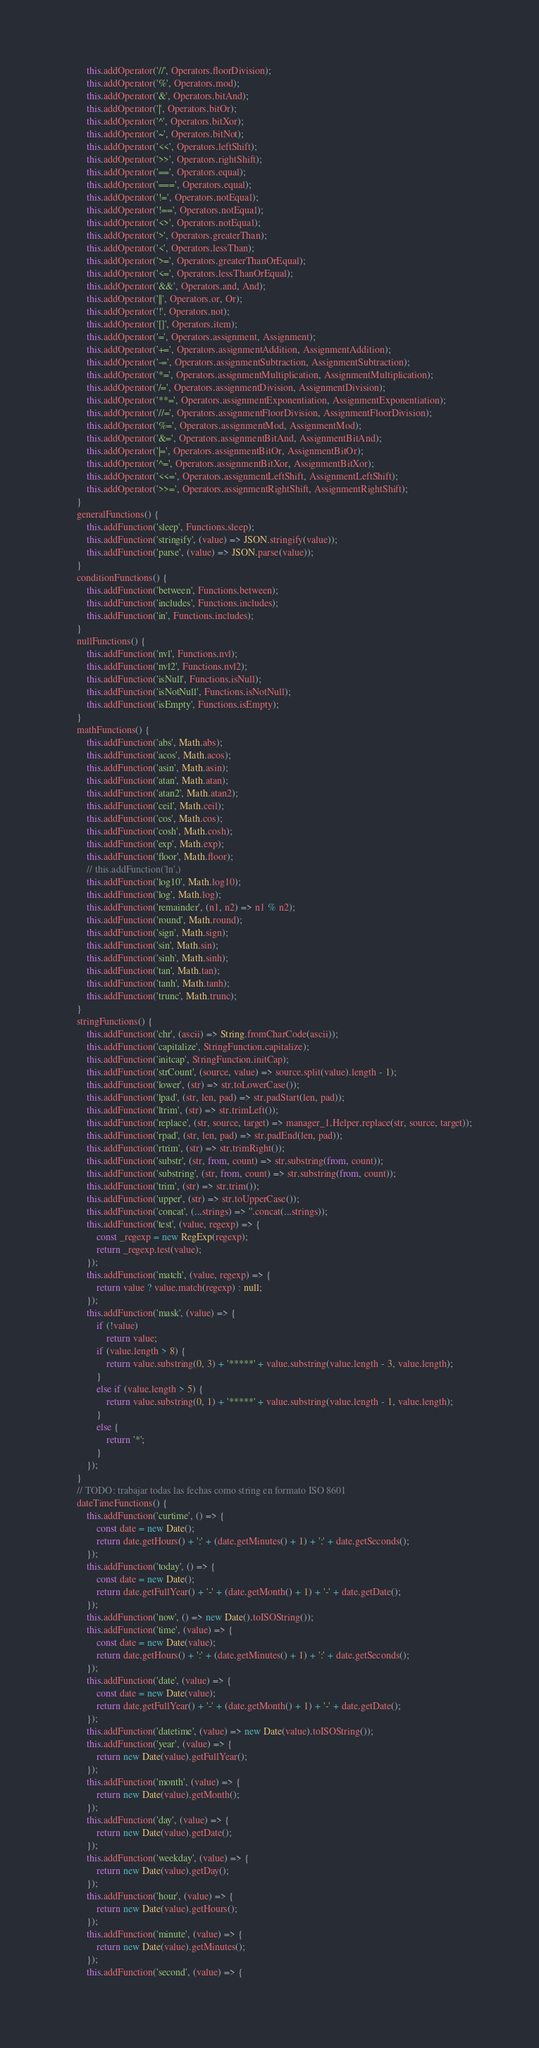Convert code to text. <code><loc_0><loc_0><loc_500><loc_500><_JavaScript_>        this.addOperator('//', Operators.floorDivision);
        this.addOperator('%', Operators.mod);
        this.addOperator('&', Operators.bitAnd);
        this.addOperator('|', Operators.bitOr);
        this.addOperator('^', Operators.bitXor);
        this.addOperator('~', Operators.bitNot);
        this.addOperator('<<', Operators.leftShift);
        this.addOperator('>>', Operators.rightShift);
        this.addOperator('==', Operators.equal);
        this.addOperator('===', Operators.equal);
        this.addOperator('!=', Operators.notEqual);
        this.addOperator('!==', Operators.notEqual);
        this.addOperator('<>', Operators.notEqual);
        this.addOperator('>', Operators.greaterThan);
        this.addOperator('<', Operators.lessThan);
        this.addOperator('>=', Operators.greaterThanOrEqual);
        this.addOperator('<=', Operators.lessThanOrEqual);
        this.addOperator('&&', Operators.and, And);
        this.addOperator('||', Operators.or, Or);
        this.addOperator('!', Operators.not);
        this.addOperator('[]', Operators.item);
        this.addOperator('=', Operators.assignment, Assignment);
        this.addOperator('+=', Operators.assignmentAddition, AssignmentAddition);
        this.addOperator('-=', Operators.assignmentSubtraction, AssignmentSubtraction);
        this.addOperator('*=', Operators.assignmentMultiplication, AssignmentMultiplication);
        this.addOperator('/=', Operators.assignmentDivision, AssignmentDivision);
        this.addOperator('**=', Operators.assignmentExponentiation, AssignmentExponentiation);
        this.addOperator('//=', Operators.assignmentFloorDivision, AssignmentFloorDivision);
        this.addOperator('%=', Operators.assignmentMod, AssignmentMod);
        this.addOperator('&=', Operators.assignmentBitAnd, AssignmentBitAnd);
        this.addOperator('|=', Operators.assignmentBitOr, AssignmentBitOr);
        this.addOperator('^=', Operators.assignmentBitXor, AssignmentBitXor);
        this.addOperator('<<=', Operators.assignmentLeftShift, AssignmentLeftShift);
        this.addOperator('>>=', Operators.assignmentRightShift, AssignmentRightShift);
    }
    generalFunctions() {
        this.addFunction('sleep', Functions.sleep);
        this.addFunction('stringify', (value) => JSON.stringify(value));
        this.addFunction('parse', (value) => JSON.parse(value));
    }
    conditionFunctions() {
        this.addFunction('between', Functions.between);
        this.addFunction('includes', Functions.includes);
        this.addFunction('in', Functions.includes);
    }
    nullFunctions() {
        this.addFunction('nvl', Functions.nvl);
        this.addFunction('nvl2', Functions.nvl2);
        this.addFunction('isNull', Functions.isNull);
        this.addFunction('isNotNull', Functions.isNotNull);
        this.addFunction('isEmpty', Functions.isEmpty);
    }
    mathFunctions() {
        this.addFunction('abs', Math.abs);
        this.addFunction('acos', Math.acos);
        this.addFunction('asin', Math.asin);
        this.addFunction('atan', Math.atan);
        this.addFunction('atan2', Math.atan2);
        this.addFunction('ceil', Math.ceil);
        this.addFunction('cos', Math.cos);
        this.addFunction('cosh', Math.cosh);
        this.addFunction('exp', Math.exp);
        this.addFunction('floor', Math.floor);
        // this.addFunction('ln',)
        this.addFunction('log10', Math.log10);
        this.addFunction('log', Math.log);
        this.addFunction('remainder', (n1, n2) => n1 % n2);
        this.addFunction('round', Math.round);
        this.addFunction('sign', Math.sign);
        this.addFunction('sin', Math.sin);
        this.addFunction('sinh', Math.sinh);
        this.addFunction('tan', Math.tan);
        this.addFunction('tanh', Math.tanh);
        this.addFunction('trunc', Math.trunc);
    }
    stringFunctions() {
        this.addFunction('chr', (ascii) => String.fromCharCode(ascii));
        this.addFunction('capitalize', StringFunction.capitalize);
        this.addFunction('initcap', StringFunction.initCap);
        this.addFunction('strCount', (source, value) => source.split(value).length - 1);
        this.addFunction('lower', (str) => str.toLowerCase());
        this.addFunction('lpad', (str, len, pad) => str.padStart(len, pad));
        this.addFunction('ltrim', (str) => str.trimLeft());
        this.addFunction('replace', (str, source, target) => manager_1.Helper.replace(str, source, target));
        this.addFunction('rpad', (str, len, pad) => str.padEnd(len, pad));
        this.addFunction('rtrim', (str) => str.trimRight());
        this.addFunction('substr', (str, from, count) => str.substring(from, count));
        this.addFunction('substring', (str, from, count) => str.substring(from, count));
        this.addFunction('trim', (str) => str.trim());
        this.addFunction('upper', (str) => str.toUpperCase());
        this.addFunction('concat', (...strings) => ''.concat(...strings));
        this.addFunction('test', (value, regexp) => {
            const _regexp = new RegExp(regexp);
            return _regexp.test(value);
        });
        this.addFunction('match', (value, regexp) => {
            return value ? value.match(regexp) : null;
        });
        this.addFunction('mask', (value) => {
            if (!value)
                return value;
            if (value.length > 8) {
                return value.substring(0, 3) + '*****' + value.substring(value.length - 3, value.length);
            }
            else if (value.length > 5) {
                return value.substring(0, 1) + '*****' + value.substring(value.length - 1, value.length);
            }
            else {
                return '*';
            }
        });
    }
    // TODO: trabajar todas las fechas como string en formato ISO 8601
    dateTimeFunctions() {
        this.addFunction('curtime', () => {
            const date = new Date();
            return date.getHours() + ':' + (date.getMinutes() + 1) + ':' + date.getSeconds();
        });
        this.addFunction('today', () => {
            const date = new Date();
            return date.getFullYear() + '-' + (date.getMonth() + 1) + '-' + date.getDate();
        });
        this.addFunction('now', () => new Date().toISOString());
        this.addFunction('time', (value) => {
            const date = new Date(value);
            return date.getHours() + ':' + (date.getMinutes() + 1) + ':' + date.getSeconds();
        });
        this.addFunction('date', (value) => {
            const date = new Date(value);
            return date.getFullYear() + '-' + (date.getMonth() + 1) + '-' + date.getDate();
        });
        this.addFunction('datetime', (value) => new Date(value).toISOString());
        this.addFunction('year', (value) => {
            return new Date(value).getFullYear();
        });
        this.addFunction('month', (value) => {
            return new Date(value).getMonth();
        });
        this.addFunction('day', (value) => {
            return new Date(value).getDate();
        });
        this.addFunction('weekday', (value) => {
            return new Date(value).getDay();
        });
        this.addFunction('hour', (value) => {
            return new Date(value).getHours();
        });
        this.addFunction('minute', (value) => {
            return new Date(value).getMinutes();
        });
        this.addFunction('second', (value) => {</code> 